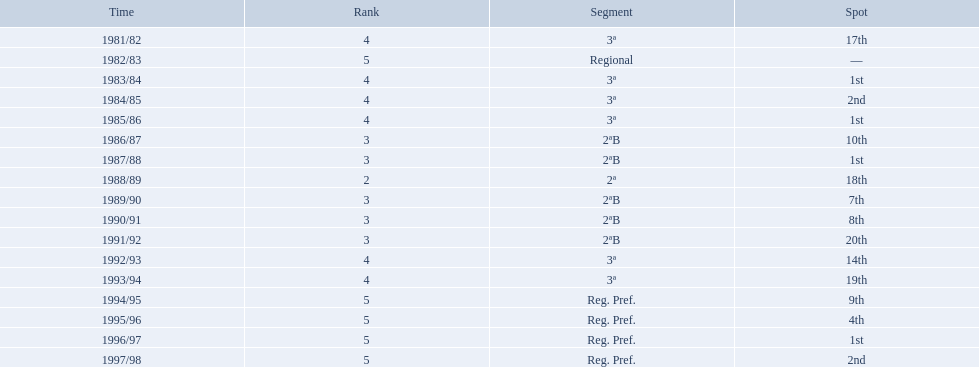In what years did the team finish 17th or worse? 1981/82, 1988/89, 1991/92, 1993/94. Of those, in which year the team finish worse? 1991/92. 